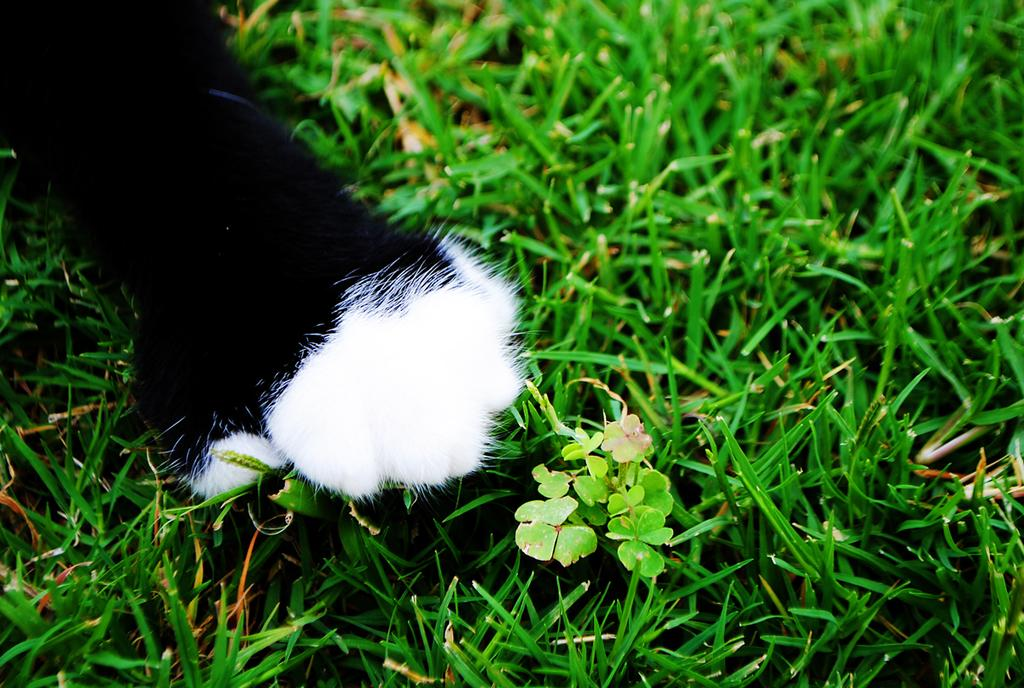What is the main subject of the image? The main subject of the image is an animal's hand. Where is the animal's hand located in the image? The animal's hand is on the grass. What type of cat can be seen leading a group of people in the image? There is no cat present in the image, and the animal's hand does not appear to be leading a group of people. 